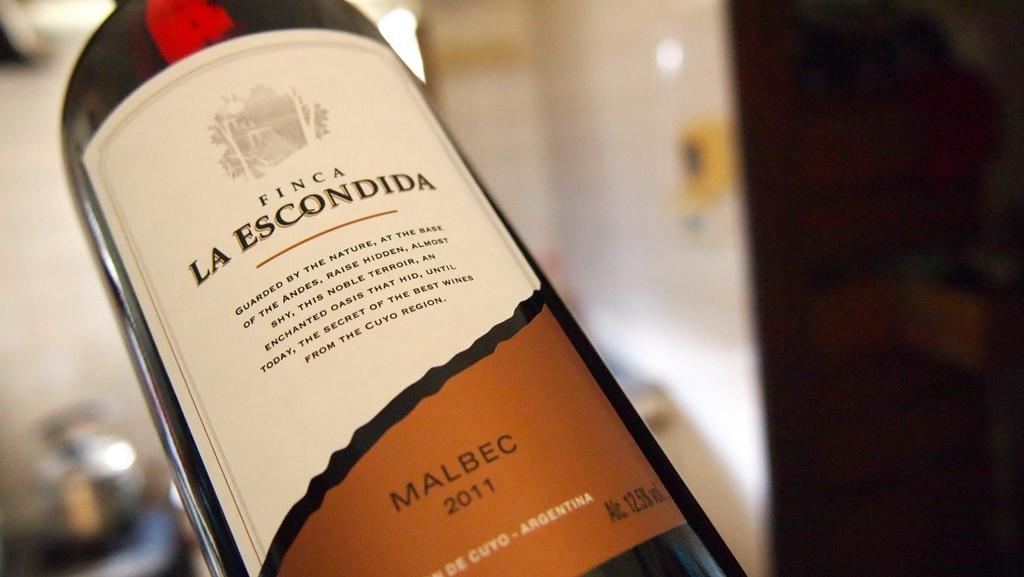Where was this wine produced?
Offer a terse response. Argentina. What year was the wine produced?
Offer a very short reply. 2011. 